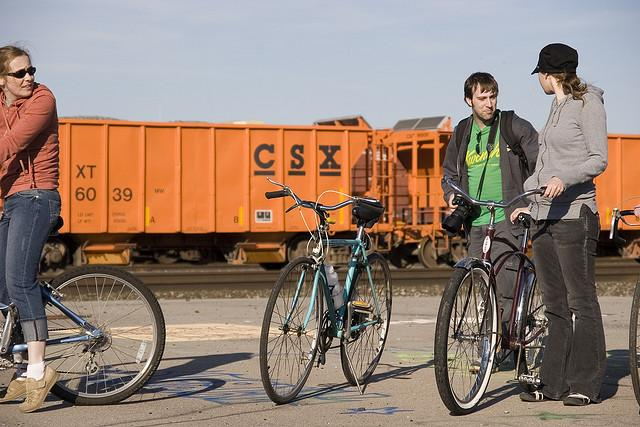How many motors are on the vehicles used by the people shown here to get them here? Please explain your reasoning. none. All of these people are standing around their bicycles. they don't require any engines to move. 